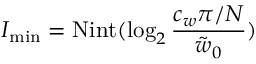<formula> <loc_0><loc_0><loc_500><loc_500>I _ { \min } = N i n t ( \log _ { 2 } \frac { c _ { w } \pi / N } { \tilde { w } _ { 0 } } )</formula> 